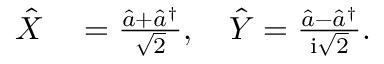Convert formula to latex. <formula><loc_0><loc_0><loc_500><loc_500>\begin{array} { r l } { \hat { X } } & = \frac { \hat { a } + \hat { a } ^ { \dagger } } { \sqrt { 2 } } , \quad \hat { Y } = \frac { \hat { a } - \hat { a } ^ { \dagger } } { i \sqrt { 2 } } . } \end{array}</formula> 